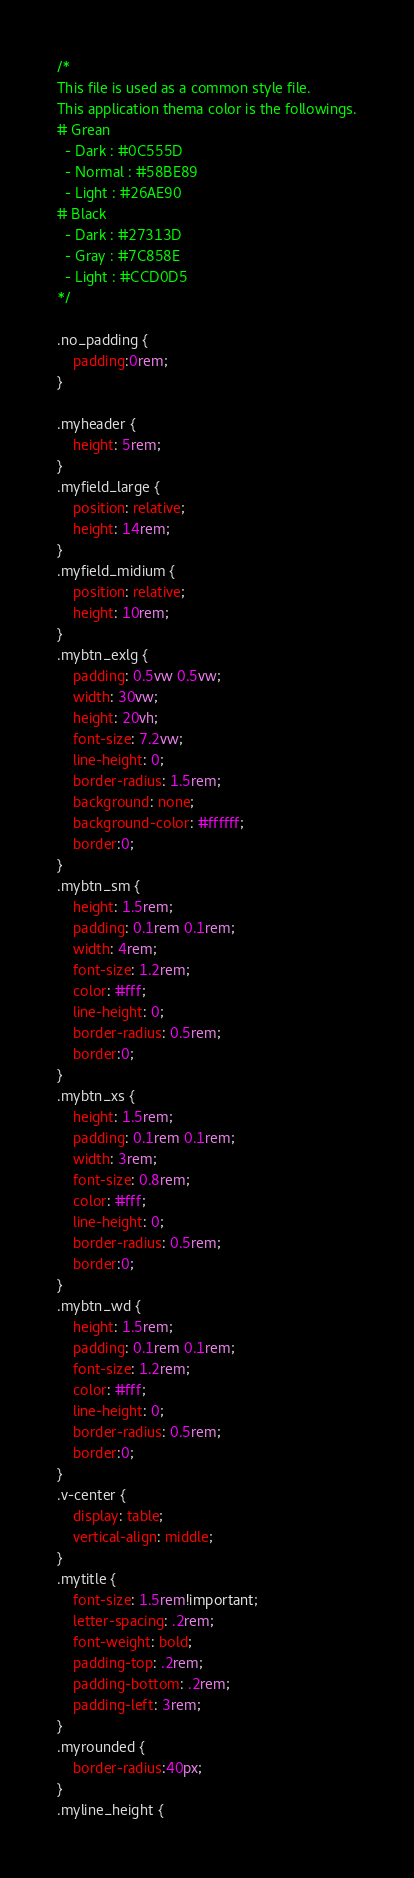Convert code to text. <code><loc_0><loc_0><loc_500><loc_500><_CSS_>/*
This file is used as a common style file.
This application thema color is the followings.
# Grean
  - Dark : #0C555D
  - Normal : #58BE89
  - Light : #26AE90
# Black
  - Dark : #27313D
  - Gray : #7C858E
  - Light : #CCD0D5
*/

.no_padding {
    padding:0rem;
}

.myheader { 
    height: 5rem;
}
.myfield_large {
    position: relative;
    height: 14rem;
}
.myfield_midium {
    position: relative;
    height: 10rem;
}
.mybtn_exlg {
    padding: 0.5vw 0.5vw;
    width: 30vw;
    height: 20vh;
    font-size: 7.2vw;
    line-height: 0;
    border-radius: 1.5rem; 
    background: none;
    background-color: #ffffff;
    border:0;
}
.mybtn_sm {
    height: 1.5rem;
    padding: 0.1rem 0.1rem;
    width: 4rem;
    font-size: 1.2rem;
    color: #fff;
    line-height: 0;
    border-radius: 0.5rem; 
    border:0;
}
.mybtn_xs {
    height: 1.5rem;
    padding: 0.1rem 0.1rem;
    width: 3rem;
    font-size: 0.8rem;
    color: #fff;
    line-height: 0;
    border-radius: 0.5rem; 
    border:0;
}
.mybtn_wd {
    height: 1.5rem;
    padding: 0.1rem 0.1rem;
    font-size: 1.2rem;
    color: #fff;
    line-height: 0;
    border-radius: 0.5rem; 
    border:0;
}
.v-center {
    display: table;
    vertical-align: middle;
}
.mytitle {
    font-size: 1.5rem!important;
    letter-spacing: .2rem;
    font-weight: bold; 
    padding-top: .2rem;
    padding-bottom: .2rem;
    padding-left: 3rem;
}
.myrounded {
    border-radius:40px;
}
.myline_height {</code> 